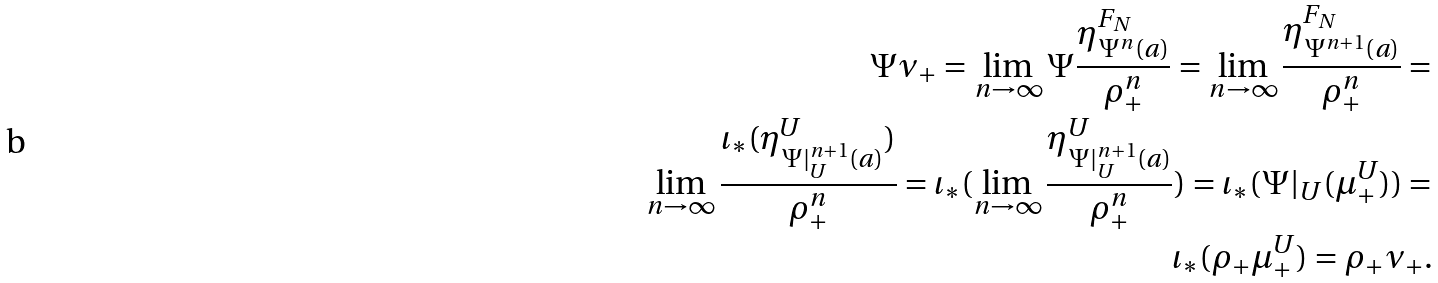<formula> <loc_0><loc_0><loc_500><loc_500>\Psi \nu _ { + } = \lim _ { n \to \infty } \Psi \frac { \eta ^ { F _ { N } } _ { \Psi ^ { n } ( a ) } } { \rho _ { + } ^ { n } } = \lim _ { n \to \infty } \frac { \eta ^ { F _ { N } } _ { \Psi ^ { n + 1 } ( a ) } } { \rho _ { + } ^ { n } } = \\ \lim _ { n \to \infty } \frac { \iota _ { \ast } ( \eta ^ { U } _ { \Psi | _ { U } ^ { n + 1 } ( a ) } ) } { \rho _ { + } ^ { n } } = \iota _ { \ast } ( \lim _ { n \to \infty } \frac { \eta ^ { U } _ { \Psi | _ { U } ^ { n + 1 } ( a ) } } { \rho _ { + } ^ { n } } ) = \iota _ { \ast } ( \Psi | _ { U } ( \mu _ { + } ^ { U } ) ) = \\ \iota _ { \ast } ( \rho _ { + } \mu _ { + } ^ { U } ) = \rho _ { + } \nu _ { + } .</formula> 